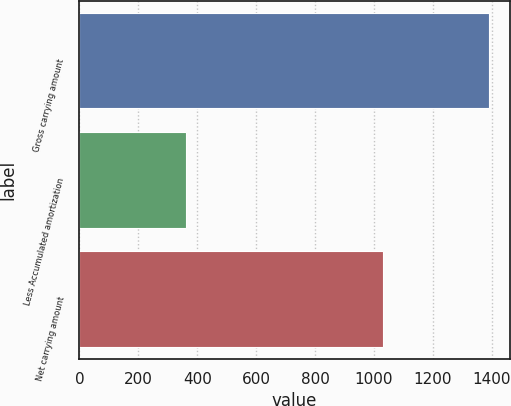<chart> <loc_0><loc_0><loc_500><loc_500><bar_chart><fcel>Gross carrying amount<fcel>Less Accumulated amortization<fcel>Net carrying amount<nl><fcel>1392<fcel>361<fcel>1031<nl></chart> 